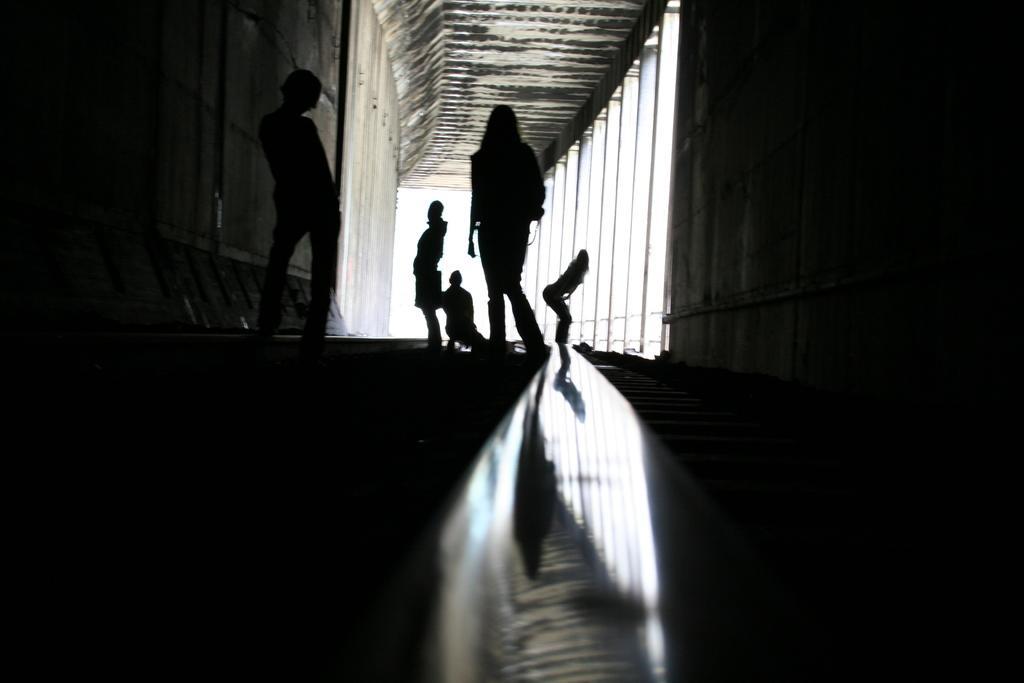How would you summarize this image in a sentence or two? In this image I can see five persons on the floor, pillars and a wall. This image is taken, may be in a building. 